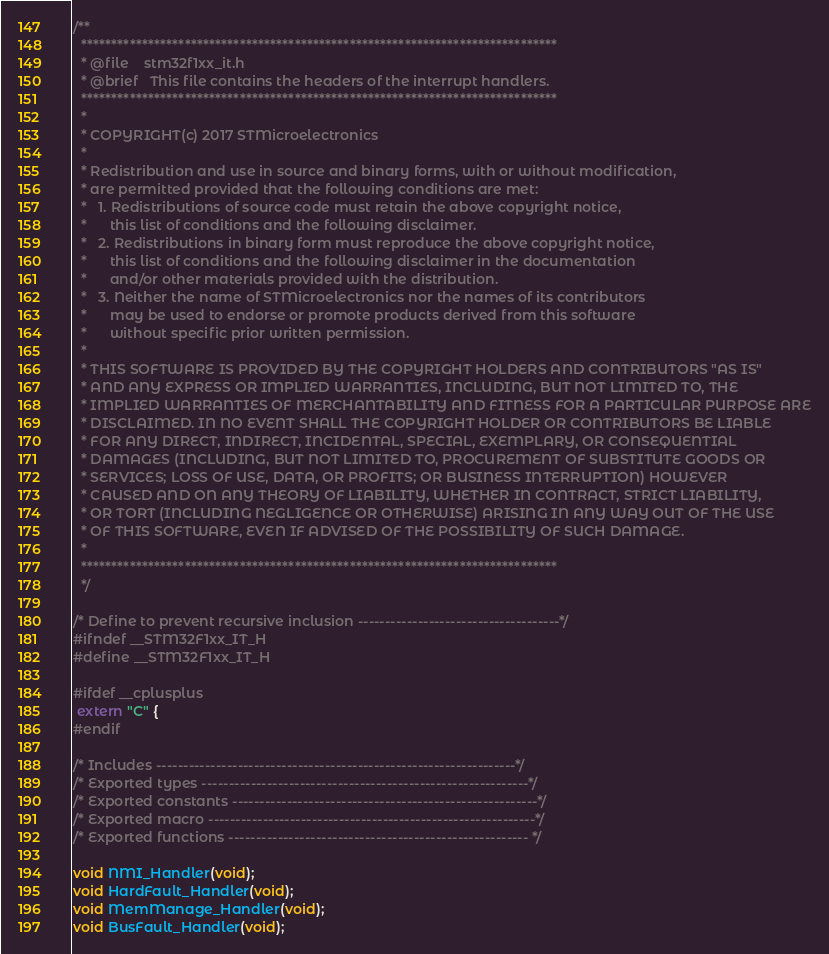<code> <loc_0><loc_0><loc_500><loc_500><_C_>/**
  ******************************************************************************
  * @file    stm32f1xx_it.h
  * @brief   This file contains the headers of the interrupt handlers.
  ******************************************************************************
  *
  * COPYRIGHT(c) 2017 STMicroelectronics
  *
  * Redistribution and use in source and binary forms, with or without modification,
  * are permitted provided that the following conditions are met:
  *   1. Redistributions of source code must retain the above copyright notice,
  *      this list of conditions and the following disclaimer.
  *   2. Redistributions in binary form must reproduce the above copyright notice,
  *      this list of conditions and the following disclaimer in the documentation
  *      and/or other materials provided with the distribution.
  *   3. Neither the name of STMicroelectronics nor the names of its contributors
  *      may be used to endorse or promote products derived from this software
  *      without specific prior written permission.
  *
  * THIS SOFTWARE IS PROVIDED BY THE COPYRIGHT HOLDERS AND CONTRIBUTORS "AS IS"
  * AND ANY EXPRESS OR IMPLIED WARRANTIES, INCLUDING, BUT NOT LIMITED TO, THE
  * IMPLIED WARRANTIES OF MERCHANTABILITY AND FITNESS FOR A PARTICULAR PURPOSE ARE
  * DISCLAIMED. IN NO EVENT SHALL THE COPYRIGHT HOLDER OR CONTRIBUTORS BE LIABLE
  * FOR ANY DIRECT, INDIRECT, INCIDENTAL, SPECIAL, EXEMPLARY, OR CONSEQUENTIAL
  * DAMAGES (INCLUDING, BUT NOT LIMITED TO, PROCUREMENT OF SUBSTITUTE GOODS OR
  * SERVICES; LOSS OF USE, DATA, OR PROFITS; OR BUSINESS INTERRUPTION) HOWEVER
  * CAUSED AND ON ANY THEORY OF LIABILITY, WHETHER IN CONTRACT, STRICT LIABILITY,
  * OR TORT (INCLUDING NEGLIGENCE OR OTHERWISE) ARISING IN ANY WAY OUT OF THE USE
  * OF THIS SOFTWARE, EVEN IF ADVISED OF THE POSSIBILITY OF SUCH DAMAGE.
  *
  ******************************************************************************
  */

/* Define to prevent recursive inclusion -------------------------------------*/
#ifndef __STM32F1xx_IT_H
#define __STM32F1xx_IT_H

#ifdef __cplusplus
 extern "C" {
#endif 

/* Includes ------------------------------------------------------------------*/
/* Exported types ------------------------------------------------------------*/
/* Exported constants --------------------------------------------------------*/
/* Exported macro ------------------------------------------------------------*/
/* Exported functions ------------------------------------------------------- */

void NMI_Handler(void);
void HardFault_Handler(void);
void MemManage_Handler(void);
void BusFault_Handler(void);</code> 